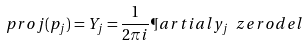<formula> <loc_0><loc_0><loc_500><loc_500>\ p r o j ( p _ { j } ) = Y _ { j } = \frac { 1 } { 2 \pi i } \P a r t i a l { y _ { j } } \ z e r o d e l</formula> 